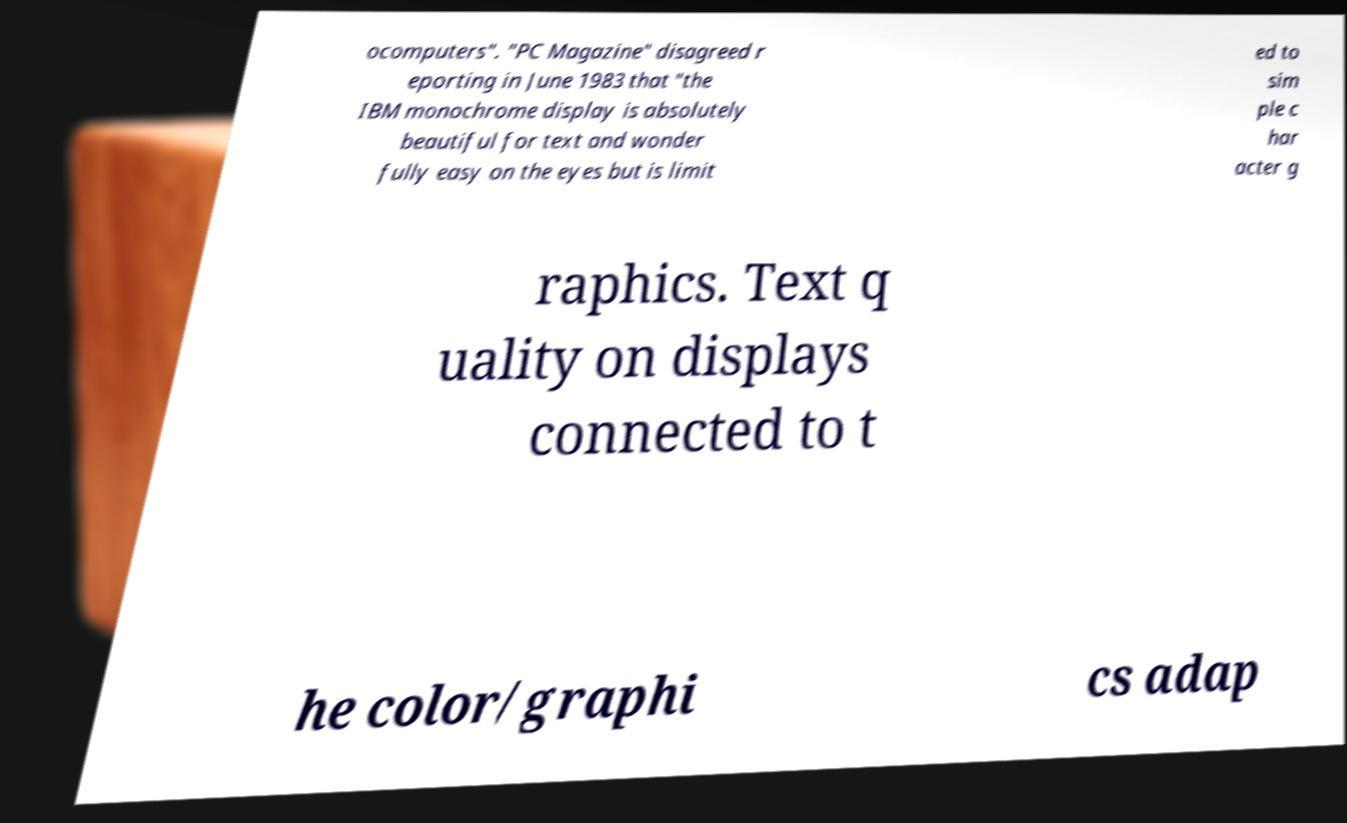I need the written content from this picture converted into text. Can you do that? ocomputers". "PC Magazine" disagreed r eporting in June 1983 that "the IBM monochrome display is absolutely beautiful for text and wonder fully easy on the eyes but is limit ed to sim ple c har acter g raphics. Text q uality on displays connected to t he color/graphi cs adap 